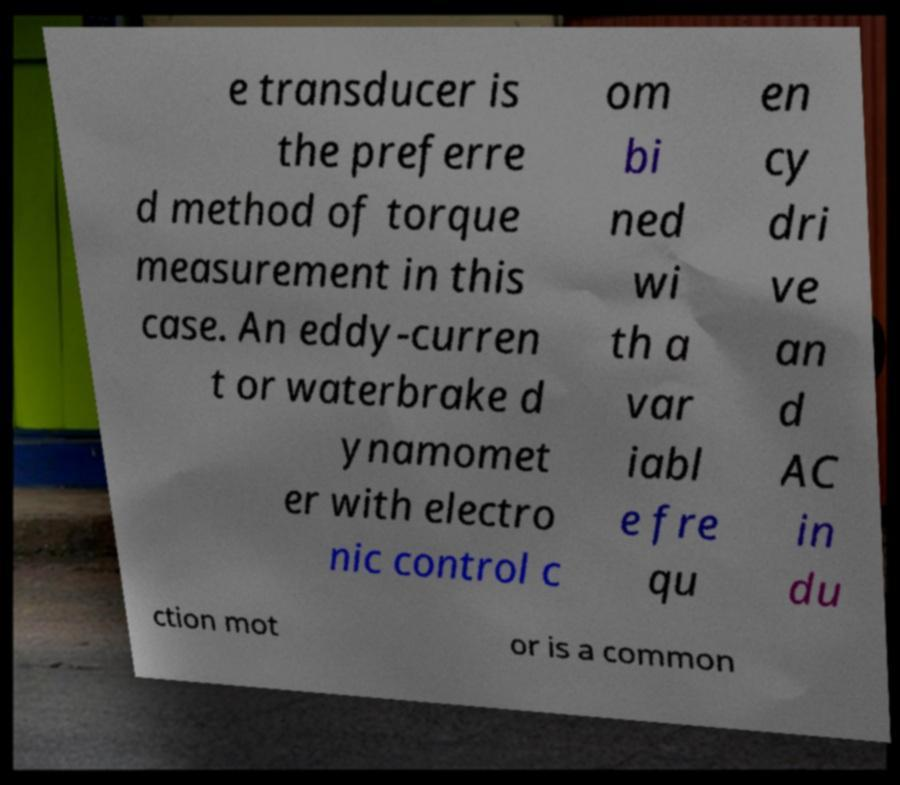What messages or text are displayed in this image? I need them in a readable, typed format. e transducer is the preferre d method of torque measurement in this case. An eddy-curren t or waterbrake d ynamomet er with electro nic control c om bi ned wi th a var iabl e fre qu en cy dri ve an d AC in du ction mot or is a common 